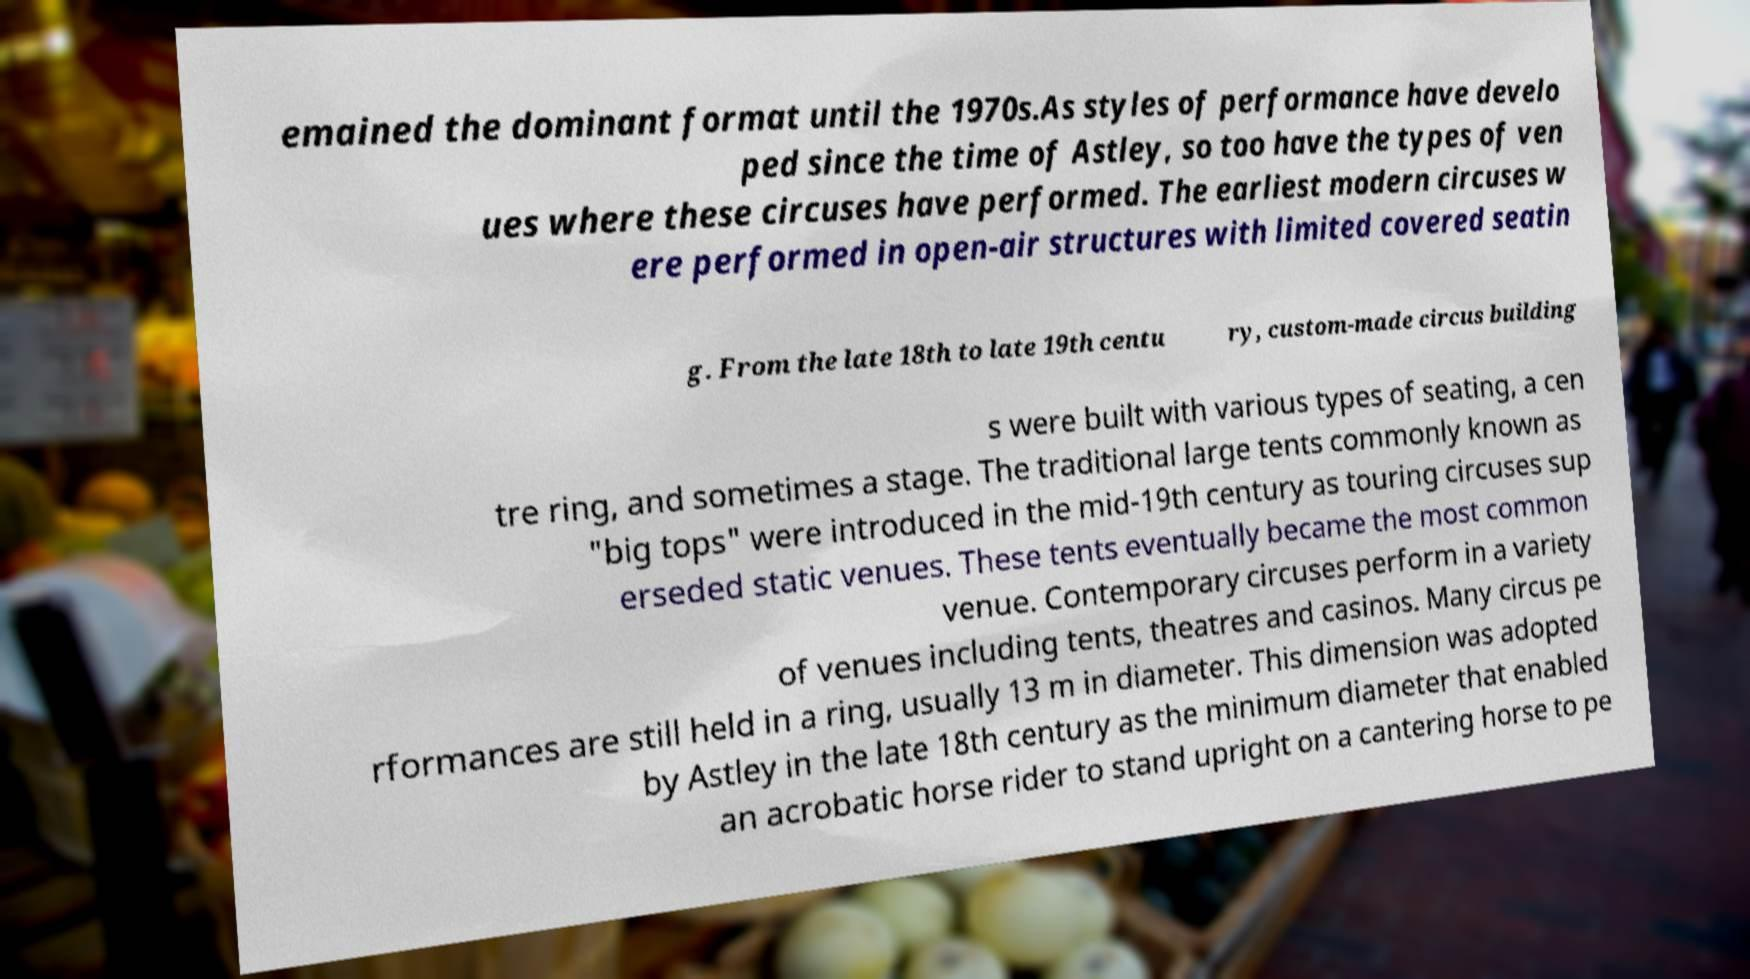Please identify and transcribe the text found in this image. emained the dominant format until the 1970s.As styles of performance have develo ped since the time of Astley, so too have the types of ven ues where these circuses have performed. The earliest modern circuses w ere performed in open-air structures with limited covered seatin g. From the late 18th to late 19th centu ry, custom-made circus building s were built with various types of seating, a cen tre ring, and sometimes a stage. The traditional large tents commonly known as "big tops" were introduced in the mid-19th century as touring circuses sup erseded static venues. These tents eventually became the most common venue. Contemporary circuses perform in a variety of venues including tents, theatres and casinos. Many circus pe rformances are still held in a ring, usually 13 m in diameter. This dimension was adopted by Astley in the late 18th century as the minimum diameter that enabled an acrobatic horse rider to stand upright on a cantering horse to pe 